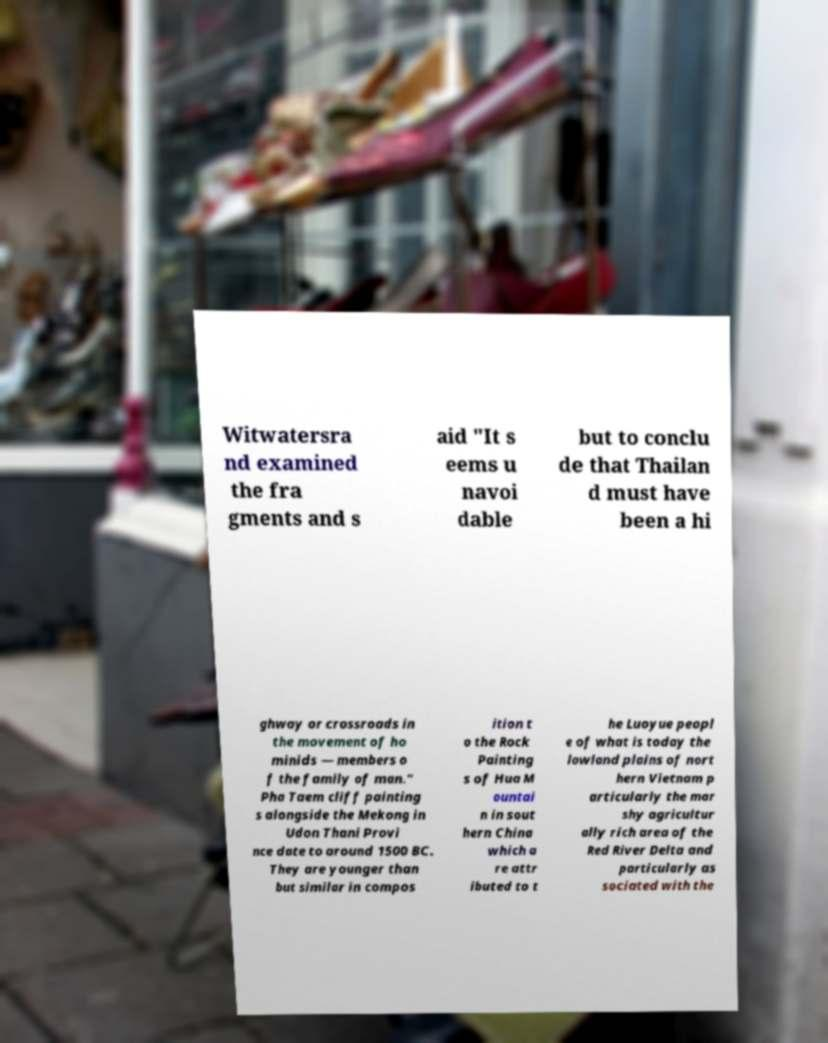Please identify and transcribe the text found in this image. Witwatersra nd examined the fra gments and s aid "It s eems u navoi dable but to conclu de that Thailan d must have been a hi ghway or crossroads in the movement of ho minids — members o f the family of man." Pha Taem cliff painting s alongside the Mekong in Udon Thani Provi nce date to around 1500 BC. They are younger than but similar in compos ition t o the Rock Painting s of Hua M ountai n in sout hern China which a re attr ibuted to t he Luoyue peopl e of what is today the lowland plains of nort hern Vietnam p articularly the mar shy agricultur ally rich area of the Red River Delta and particularly as sociated with the 